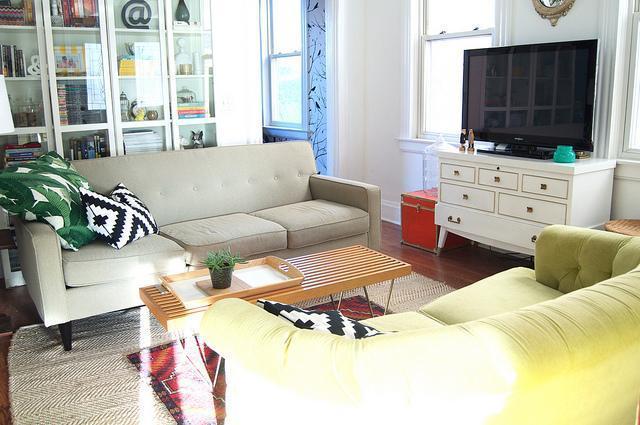How many pillows on the beige couch?
Give a very brief answer. 2. How many windows are in the picture?
Give a very brief answer. 3. How many couches are in the photo?
Give a very brief answer. 2. How many elephants are standing on two legs?
Give a very brief answer. 0. 